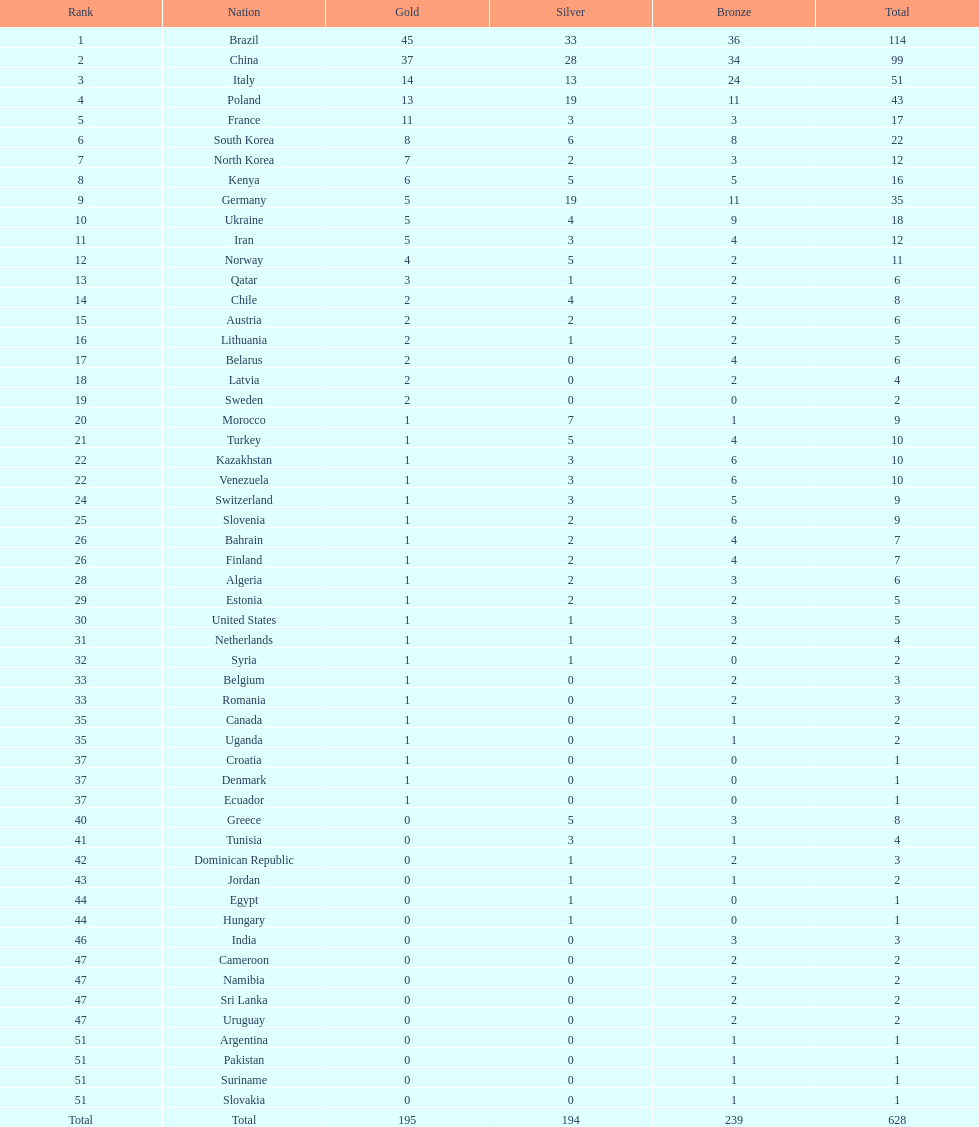Who obtained more gold medals, brazil or china? Brazil. 